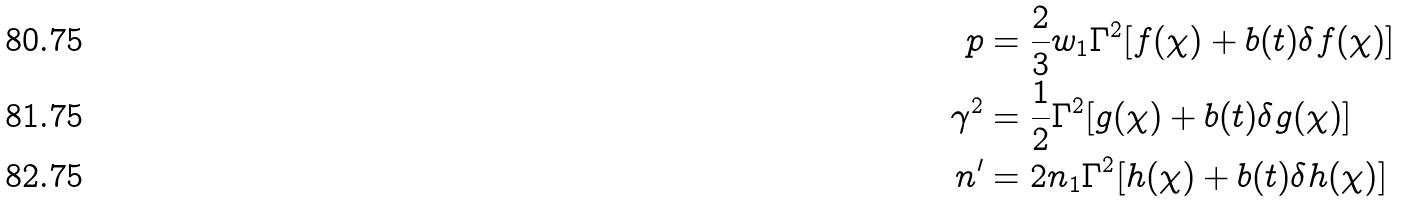Convert formula to latex. <formula><loc_0><loc_0><loc_500><loc_500>p & = \frac { 2 } { 3 } w _ { 1 } \Gamma ^ { 2 } [ f ( \chi ) + b ( t ) \delta f ( \chi ) ] \\ \gamma ^ { 2 } & = \frac { 1 } { 2 } \Gamma ^ { 2 } [ g ( \chi ) + b ( t ) \delta g ( \chi ) ] \\ n ^ { \prime } & = 2 n _ { 1 } \Gamma ^ { 2 } [ h ( \chi ) + b ( t ) \delta h ( \chi ) ]</formula> 